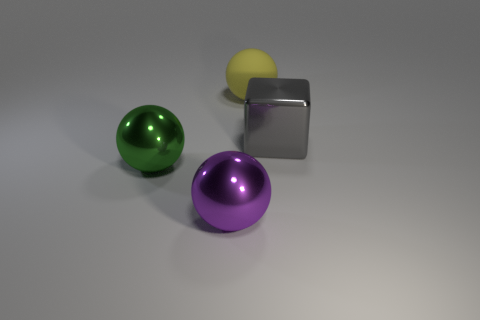There is a big sphere that is made of the same material as the green object; what color is it?
Your response must be concise. Purple. There is a big thing that is behind the large object to the right of the big yellow sphere; what color is it?
Offer a very short reply. Yellow. The green thing that is the same size as the yellow object is what shape?
Your response must be concise. Sphere. How many metal objects are left of the ball that is to the left of the purple shiny ball?
Keep it short and to the point. 0. How many other objects are the same material as the large yellow ball?
Provide a short and direct response. 0. There is a shiny thing that is behind the large ball that is to the left of the purple object; what shape is it?
Your response must be concise. Cube. What size is the metallic thing on the right side of the matte sphere?
Your response must be concise. Large. Is the big yellow sphere made of the same material as the large purple object?
Ensure brevity in your answer.  No. What is the shape of the green thing that is the same material as the gray block?
Ensure brevity in your answer.  Sphere. Is there any other thing that is the same color as the big cube?
Ensure brevity in your answer.  No. 